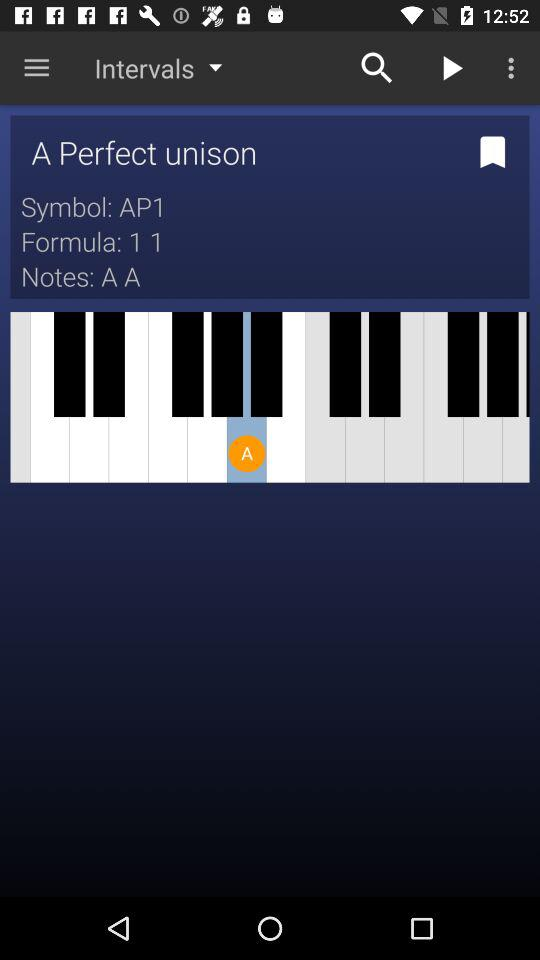How many notes are in the chord?
Answer the question using a single word or phrase. 2 